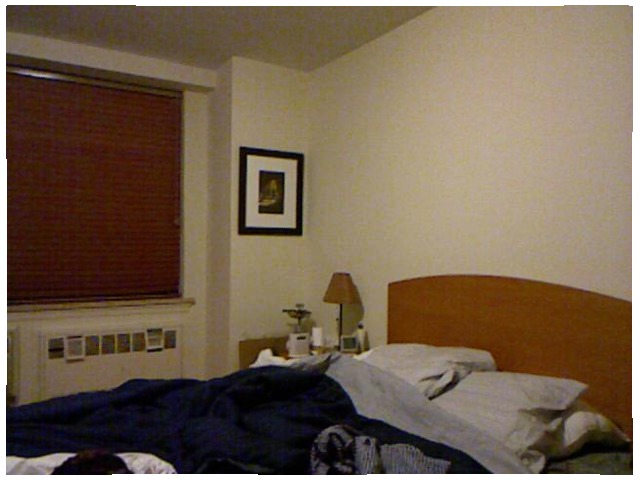<image>
Is the pillow under the blanket? Yes. The pillow is positioned underneath the blanket, with the blanket above it in the vertical space. Is there a photo on the wall? Yes. Looking at the image, I can see the photo is positioned on top of the wall, with the wall providing support. 